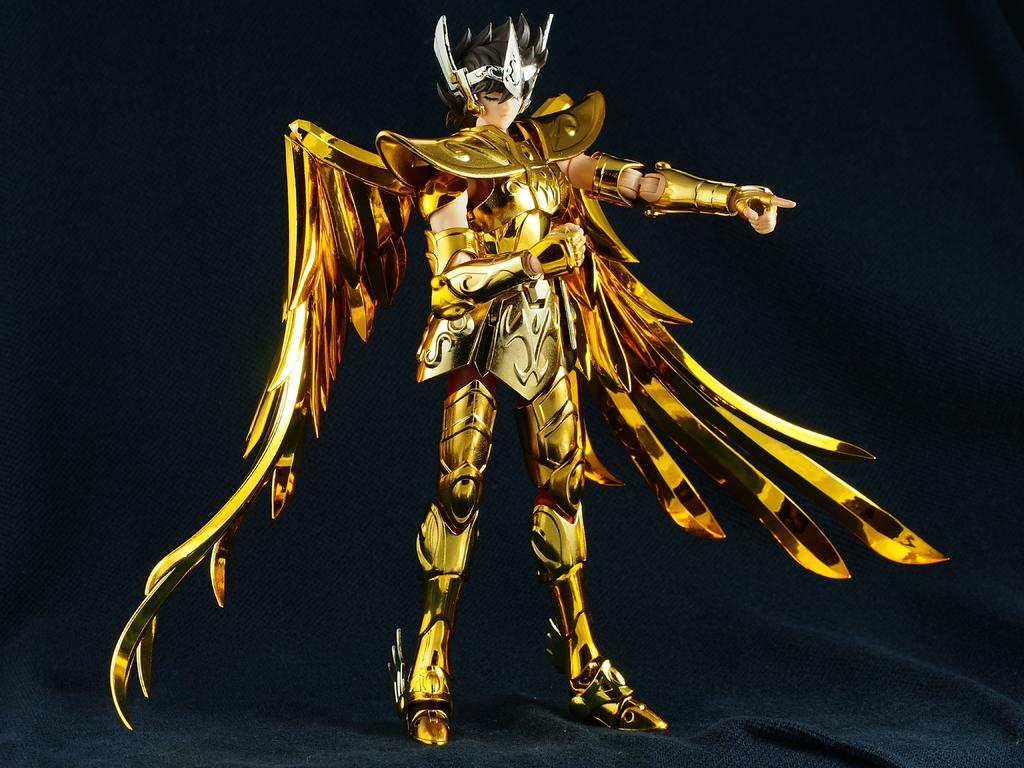What type of image is depicted in the picture? There is a cartoon picture of a person in the image. What can be observed about the background of the image? The background of the image is dark. What type of canvas is the person holding in the image? There is no canvas present in the image; it features a cartoon picture of a person with a dark background. 